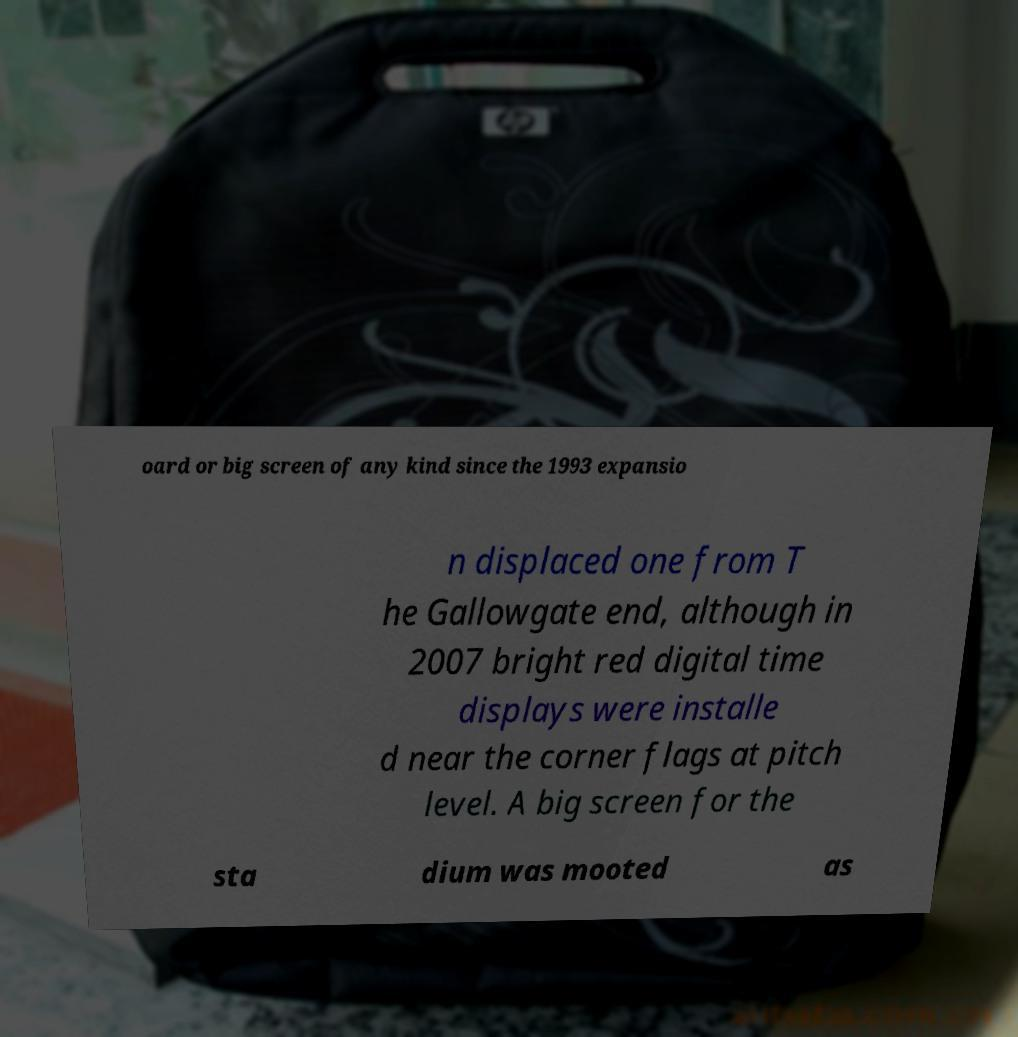Can you read and provide the text displayed in the image?This photo seems to have some interesting text. Can you extract and type it out for me? oard or big screen of any kind since the 1993 expansio n displaced one from T he Gallowgate end, although in 2007 bright red digital time displays were installe d near the corner flags at pitch level. A big screen for the sta dium was mooted as 